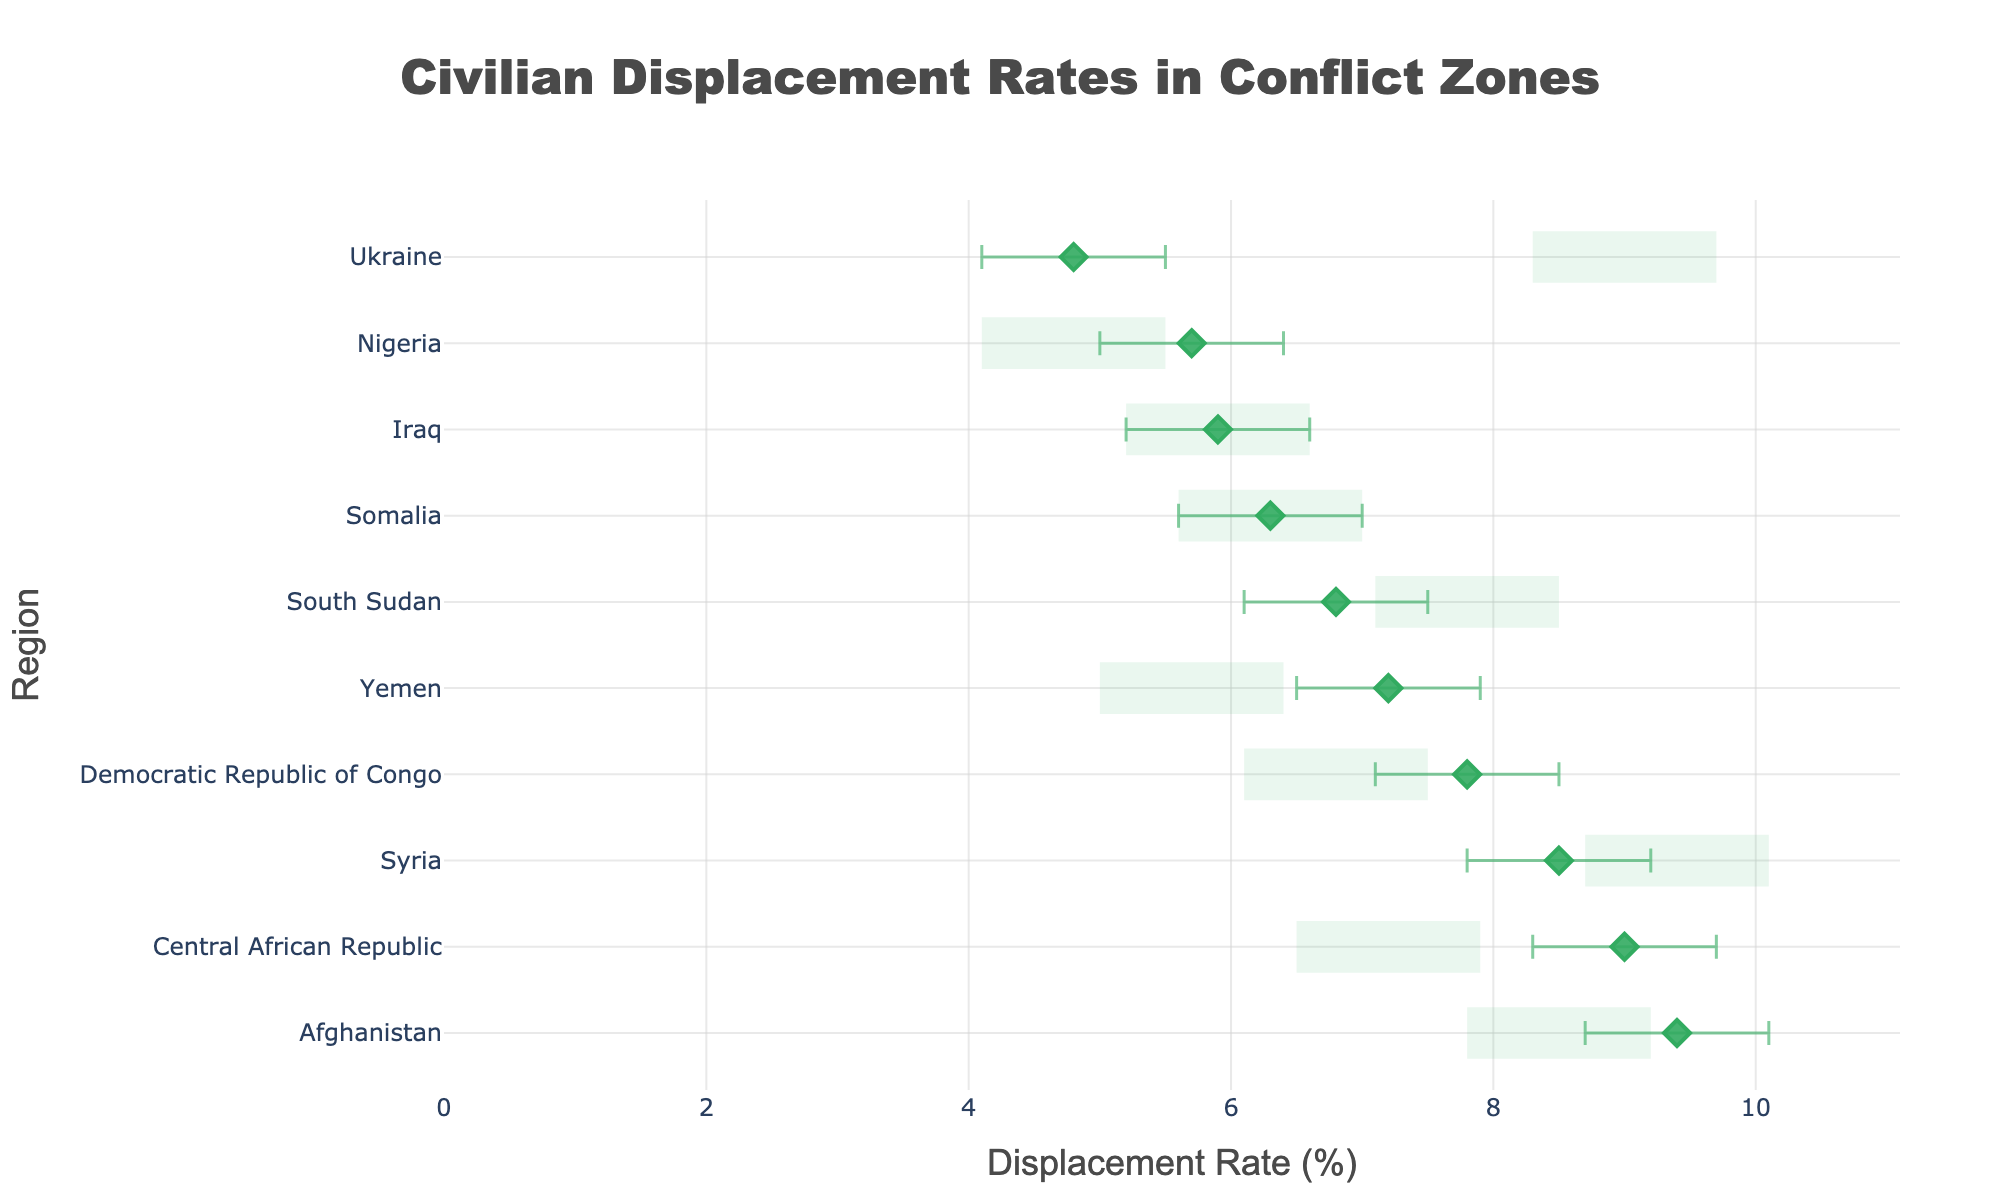What is the title of the plot? The title is located at the top center of the plot, and it reads "Civilian Displacement Rates in Conflict Zones."
Answer: Civilian Displacement Rates in Conflict Zones How many regions are represented in the plot? By counting the number of unique regional labels along the y-axis, you can determine the number of regions.
Answer: 10 Which region has the highest displacement rate? The displacement rates are plotted along the x-axis, and by looking for the point furthest to the right, you can see that Afghanistan has the highest rate at 9.4%.
Answer: Afghanistan What are the lower and upper confidence intervals for Ukraine? For Ukraine, locate its point along the y-axis, then refer to the error bars for the lower and upper bounds indicated. The lower bound is 4.1%, and the upper bound is 5.5%.
Answer: 4.1%, 5.5% Which region shows the widest confidence interval? The width of the confidence interval is found by subtracting the lower bound from the upper bound for each region. The widest interval belongs to Afghanistan, with upper and lower bounds of 10.1% and 8.7%, respectively.
Answer: Afghanistan Compare the displacement rates of Yemen and Somalia. Which is higher? Yemen and Somalia are compared by looking at their respective points on the x-axis. Yemen has a displacement rate of 7.2%, whereas Somalia has a rate of 6.3%.
Answer: Yemen What is the average displacement rate for all regions combined? Sum all displacement rates: 8.5 + 7.2 + 9.4 + 6.8 + 5.7 + 7.8 + 6.3 + 5.9 + 4.8 + 9.0 = 71.4. Then divide by the number of regions (10).
Answer: 7.14% Which two regions have displacement rates within the range of 6% to 7%? By checking each region's rate, the regions within the 6% to 7% range are South Sudan (6.8%) and Somalia (6.3%).
Answer: South Sudan, Somalia Of Syria, Yemen, and South Sudan, which has the smallest confidence interval? Calculate the interval width for each:
Syria: 9.2 - 7.8 = 1.4
Yemen: 7.9 - 6.5 = 1.4
South Sudan: 7.5 - 6.1 = 1.4
They all have the same interval width of 1.4.
Answer: Syria, Yemen, South Sudan Which region has a displacement rate closest to the average rate? The average rate is 7.14%. The region whose rate is closest to this is Democratic Republic of Congo with a rate of 7.8%.
Answer: Democratic Republic of Congo 